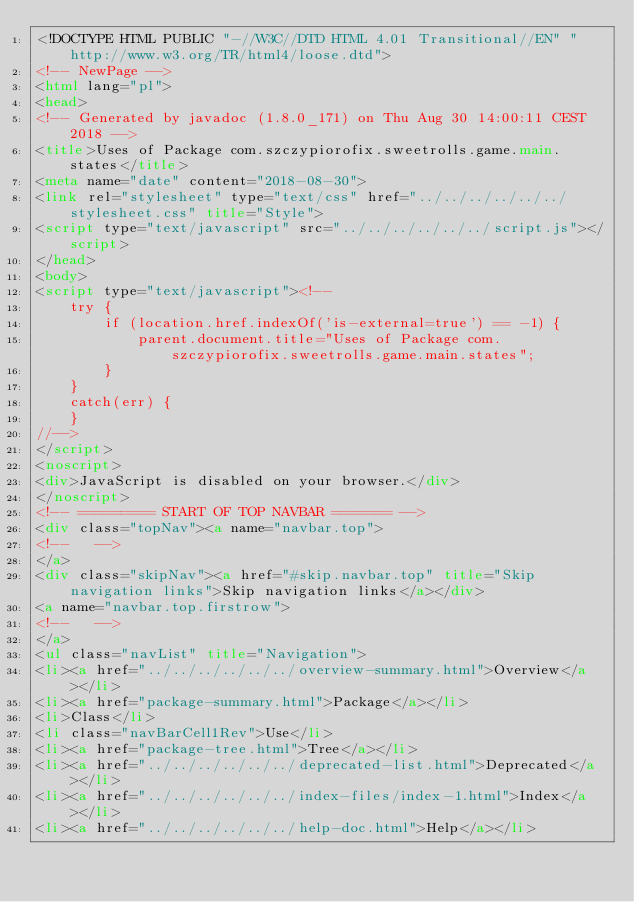<code> <loc_0><loc_0><loc_500><loc_500><_HTML_><!DOCTYPE HTML PUBLIC "-//W3C//DTD HTML 4.01 Transitional//EN" "http://www.w3.org/TR/html4/loose.dtd">
<!-- NewPage -->
<html lang="pl">
<head>
<!-- Generated by javadoc (1.8.0_171) on Thu Aug 30 14:00:11 CEST 2018 -->
<title>Uses of Package com.szczypiorofix.sweetrolls.game.main.states</title>
<meta name="date" content="2018-08-30">
<link rel="stylesheet" type="text/css" href="../../../../../../stylesheet.css" title="Style">
<script type="text/javascript" src="../../../../../../script.js"></script>
</head>
<body>
<script type="text/javascript"><!--
    try {
        if (location.href.indexOf('is-external=true') == -1) {
            parent.document.title="Uses of Package com.szczypiorofix.sweetrolls.game.main.states";
        }
    }
    catch(err) {
    }
//-->
</script>
<noscript>
<div>JavaScript is disabled on your browser.</div>
</noscript>
<!-- ========= START OF TOP NAVBAR ======= -->
<div class="topNav"><a name="navbar.top">
<!--   -->
</a>
<div class="skipNav"><a href="#skip.navbar.top" title="Skip navigation links">Skip navigation links</a></div>
<a name="navbar.top.firstrow">
<!--   -->
</a>
<ul class="navList" title="Navigation">
<li><a href="../../../../../../overview-summary.html">Overview</a></li>
<li><a href="package-summary.html">Package</a></li>
<li>Class</li>
<li class="navBarCell1Rev">Use</li>
<li><a href="package-tree.html">Tree</a></li>
<li><a href="../../../../../../deprecated-list.html">Deprecated</a></li>
<li><a href="../../../../../../index-files/index-1.html">Index</a></li>
<li><a href="../../../../../../help-doc.html">Help</a></li></code> 